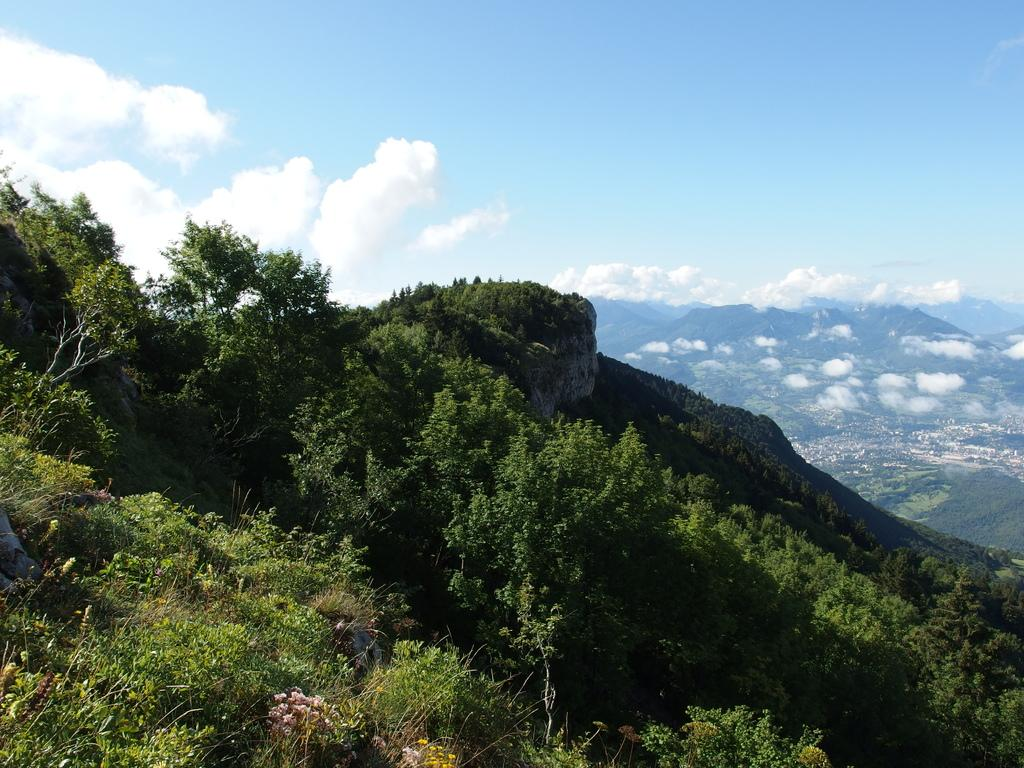What is the main subject of the image? The main subject of the image is a beautiful view of the mountains. What can be observed about the mountains in the image? The mountains are full of trees. Can you describe the background of the image? There is a mountain in the background of the image. What is the color of the sky in the image? The sky is blue in the image. What else can be seen in the sky? Clouds are visible in the image. What grade did the mountain receive for its performance in the war? There is no mention of a war or a grade in the image, as it features a beautiful view of mountains with trees and a blue sky with clouds. 